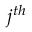Convert formula to latex. <formula><loc_0><loc_0><loc_500><loc_500>j ^ { t h }</formula> 